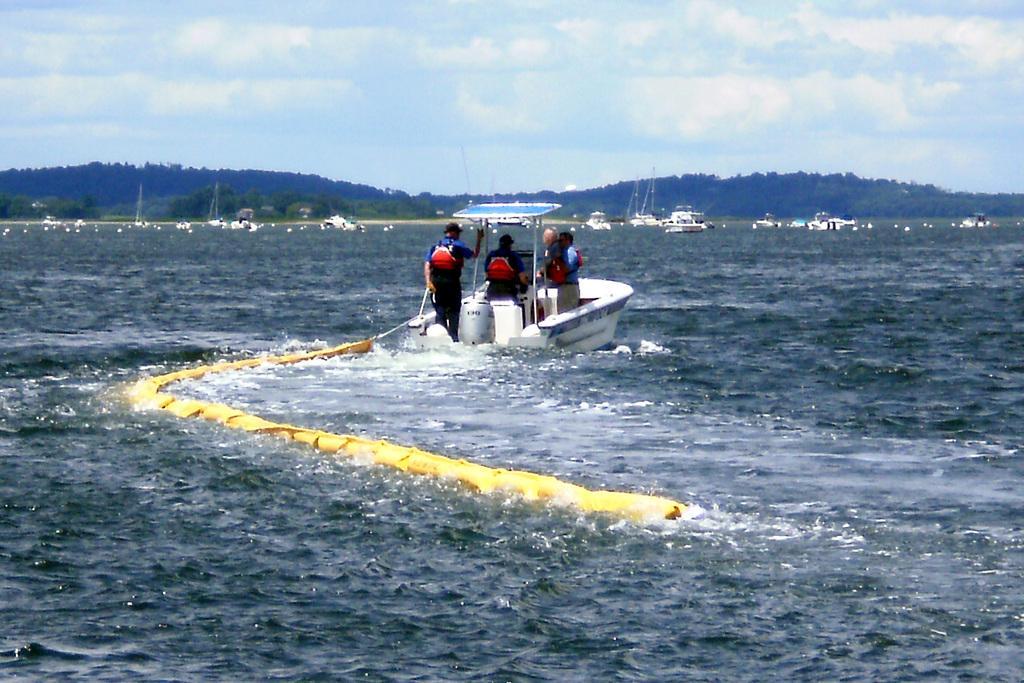How would you summarize this image in a sentence or two? In the middle of the picture, we see four men are riding the boat. Here, we see water and this water might be in the sea. There are boats and yachts in the background. There are trees and hills in the background. At the top, we see the sky. 